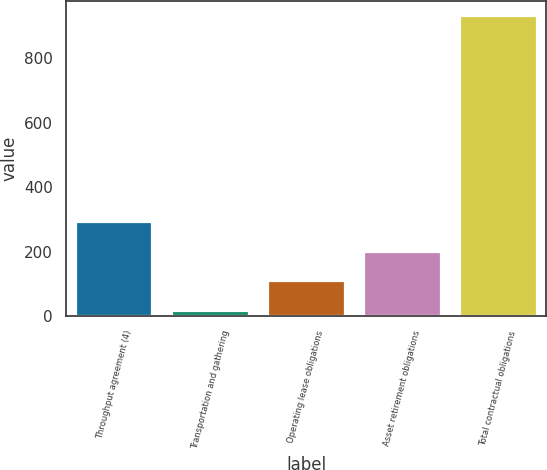Convert chart to OTSL. <chart><loc_0><loc_0><loc_500><loc_500><bar_chart><fcel>Throughput agreement (4)<fcel>Transportation and gathering<fcel>Operating lease obligations<fcel>Asset retirement obligations<fcel>Total contractual obligations<nl><fcel>291.2<fcel>17<fcel>108.4<fcel>199.8<fcel>931<nl></chart> 